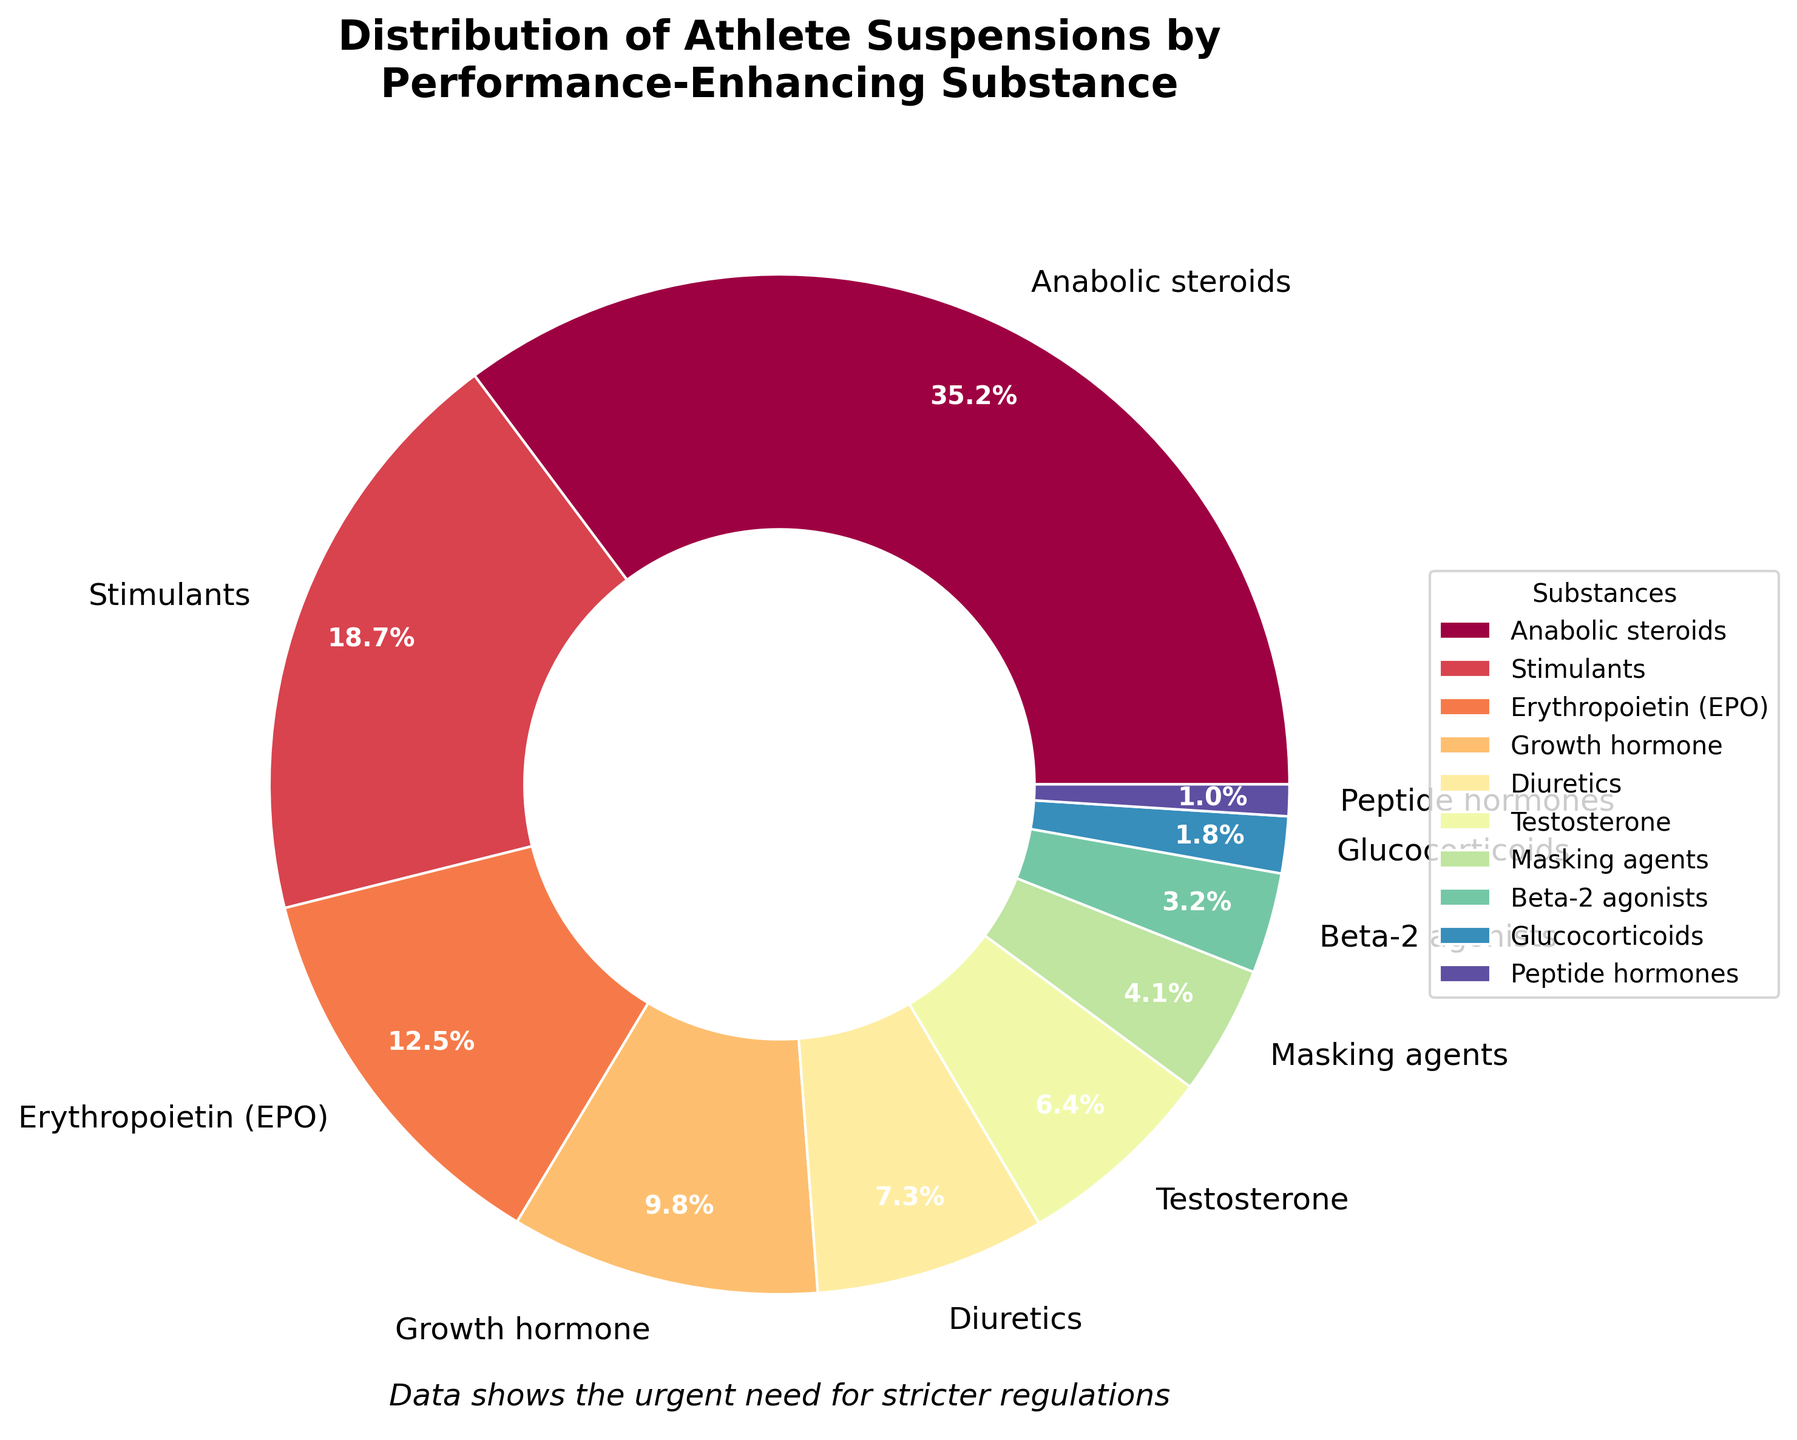What substance has the highest percentage of athlete suspensions? The largest section of the pie chart, with a percentage labeled as 35.2%, corresponds to anabolic steroids.
Answer: Anabolic steroids Which three substances have the lowest percentages of athlete suspensions? The smallest sections of the pie chart correspond to the percentages 1.0%, 1.8%, and 3.2%. These sections are labeled as peptide hormones, glucocorticoids, and beta-2 agonists, respectively.
Answer: Peptide hormones, glucocorticoids, beta-2 agonists What is the combined percentage of athlete suspensions due to anabolic steroids and stimulants? The chart shows the percentage for anabolic steroids is 35.2% and for stimulants is 18.7%. Adding these two values gives 35.2% + 18.7% = 53.9%.
Answer: 53.9% How much higher is the percentage of athlete suspensions for anabolic steroids compared to erythropoietin (EPO)? The percentage for anabolic steroids is 35.2%, and for EPO, it is 12.5%. The difference is 35.2% - 12.5% = 22.7%.
Answer: 22.7% Is the total percentage of suspensions due to masking agents and testosterone greater or less than the percentage of suspensions due to erythropoietin (EPO)? The percentages for masking agents and testosterone are 4.1% and 6.4% respectively. Adding these gives 4.1% + 6.4% = 10.5%, which is less than the 12.5% for EPO.
Answer: Less Which substance is represented by the segment with a blue color in the pie chart? The chart uses a range of colors, and examining the segment colored blue, the corresponding label is beta-2 agonists, which has a percentage of 3.2%.
Answer: Beta-2 agonists What is the combined percentage of athlete suspensions for substances with a percentage higher than 10%? The substances with percentages higher than 10% are anabolic steroids (35.2%), stimulants (18.7%), and EPO (12.5%). Adding these values gives 35.2% + 18.7% + 12.5% = 66.4%.
Answer: 66.4% What is the difference in the percentage of athlete suspensions between substances with the highest and lowest percentages? The highest percentage is for anabolic steroids (35.2%), and the lowest percentage is for peptide hormones (1.0%). The difference is 35.2% - 1.0% = 34.2%.
Answer: 34.2% What color represents the substance 'growth hormone' in the pie chart, and what is its percentage? The 'growth hormone' segment is labeled with a percentage of 9.8% and is visually colored in the chart.
Answer: 9.8% What fraction of the total percentage is made up of the top three substances causing athlete suspensions? Adding the percentages of the top three substances: anabolic steroids (35.2%), stimulants (18.7%), and EPO (12.5%) gives us 35.2% + 18.7% + 12.5% = 66.4%. Considering the total percentage is 100%, the fraction is 66.4/100.
Answer: 0.664 